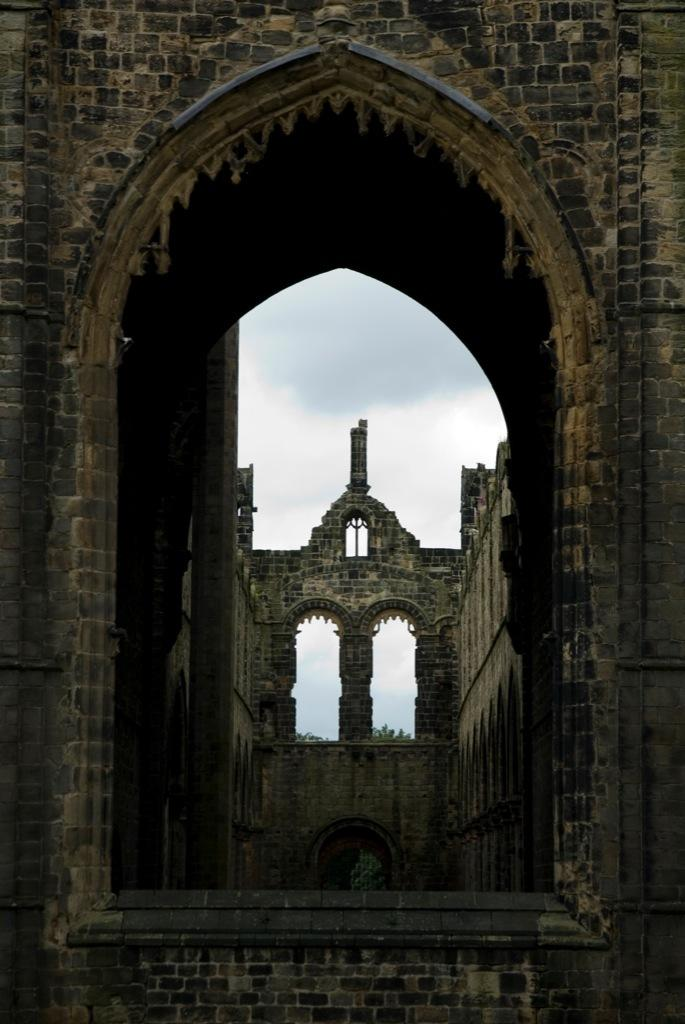What type of building is shown in the image? The image features a Kirkstall Abbey building. What can be seen in the background of the image? The sky is visible in the background of the image. How does the comb contribute to the harmony of the image? There is no comb present in the image, so it cannot contribute to the harmony of the image. 